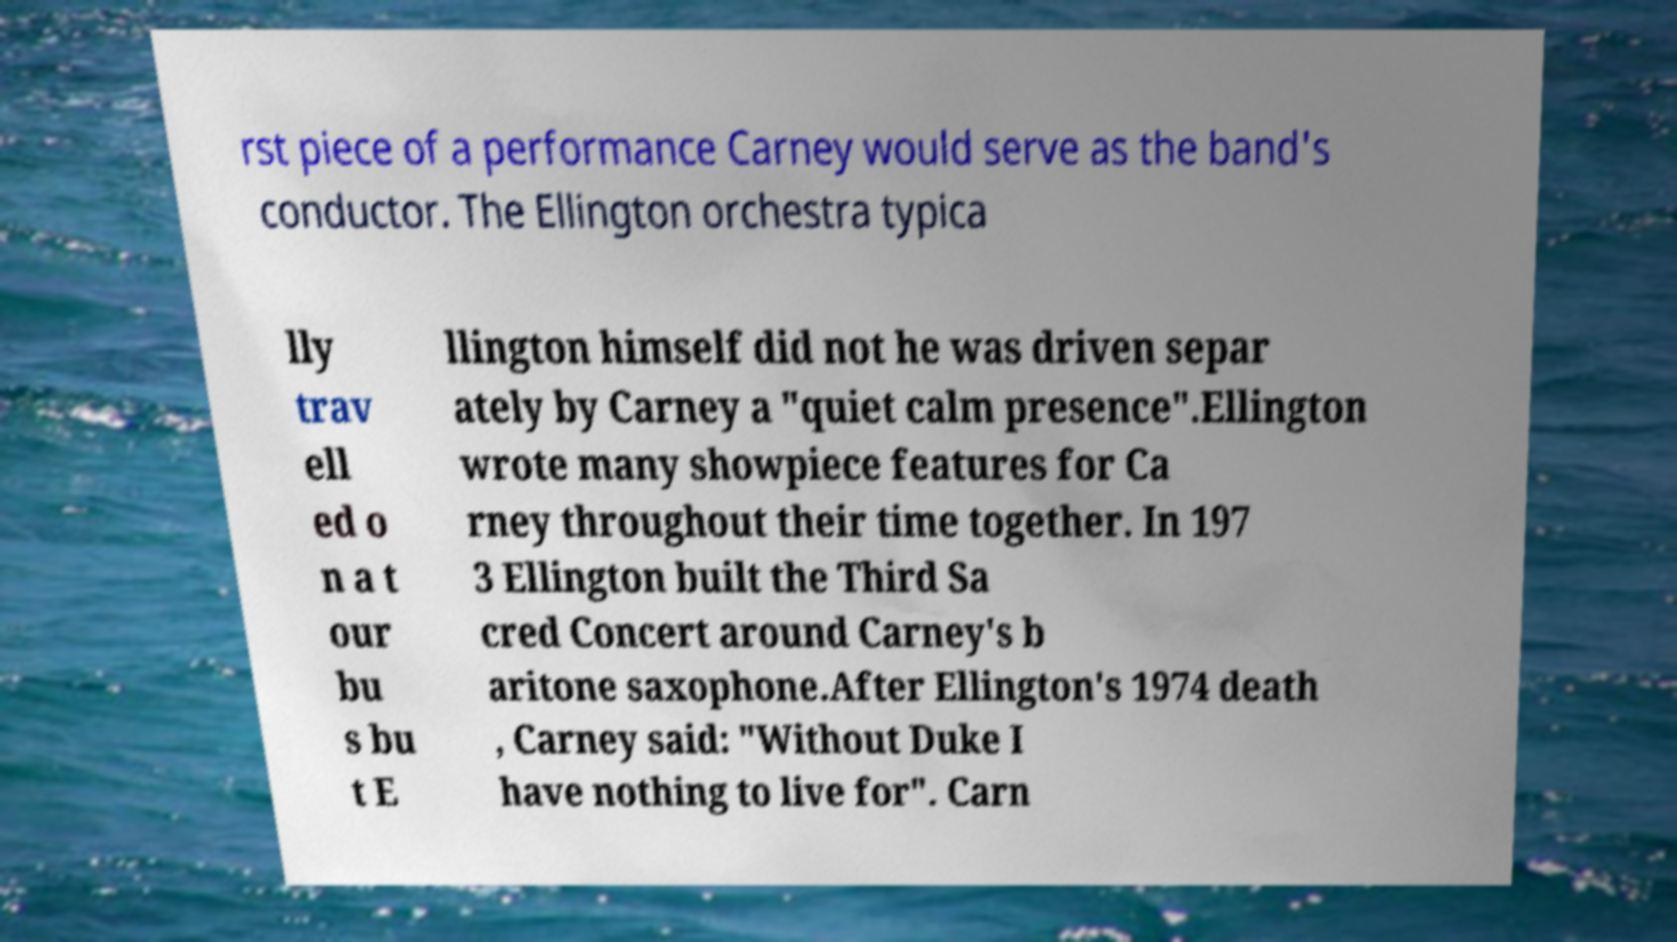For documentation purposes, I need the text within this image transcribed. Could you provide that? rst piece of a performance Carney would serve as the band's conductor. The Ellington orchestra typica lly trav ell ed o n a t our bu s bu t E llington himself did not he was driven separ ately by Carney a "quiet calm presence".Ellington wrote many showpiece features for Ca rney throughout their time together. In 197 3 Ellington built the Third Sa cred Concert around Carney's b aritone saxophone.After Ellington's 1974 death , Carney said: "Without Duke I have nothing to live for". Carn 